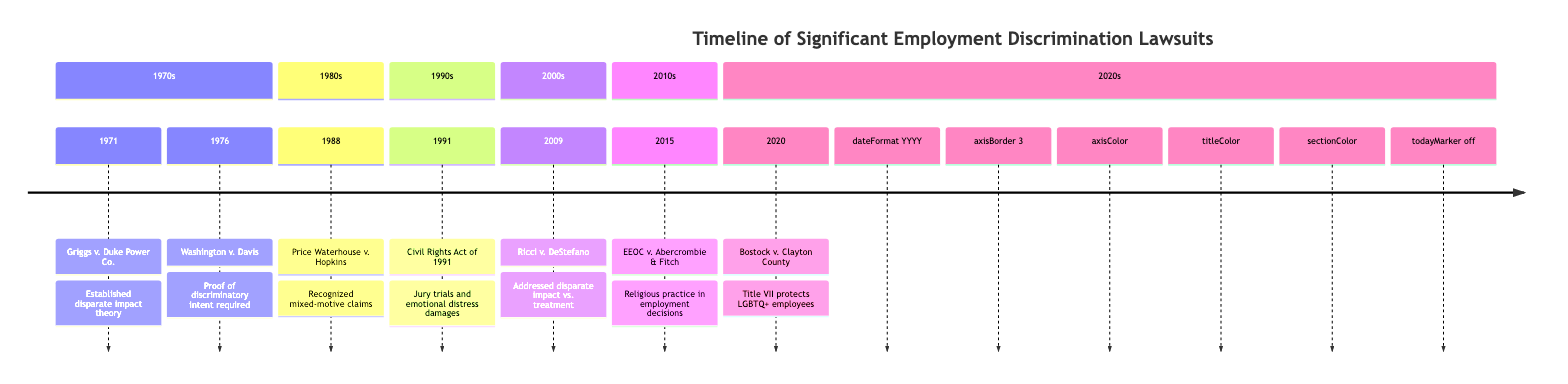What lawsuit established the disparate impact theory? The diagram indicates that the lawsuit Griggs v. Duke Power Co. in 1971 established the disparate impact theory.
Answer: Griggs v. Duke Power Co What year was Price Waterhouse v. Hopkins decided? According to the diagram, Price Waterhouse v. Hopkins was decided in 1988.
Answer: 1988 Which lawsuit required proof of discriminatory intent? The diagram shows that Washington v. Davis from 1976 required proof of discriminatory intent.
Answer: Washington v. Davis How many significant employment discrimination lawsuits are listed in the timeline? By counting the entries in the diagram, there are seven significant employment discrimination lawsuits listed.
Answer: 7 Which case addressed the balance between disparate impact and treatment? The diagram indicates that Ricci v. DeStefano, decided in 2009, addressed the issue of disparate impact versus treatment.
Answer: Ricci v. DeStefano What landmark case in 2015 dealt with religious practice in employment decisions? The diagram names EEOC v. Abercrombie & Fitch as the landmark case in 2015 dealing with religious practices in employment.
Answer: EEOC v. Abercrombie & Fitch What is the significance of Bostock v. Clayton County regarding employee protections? Bostock v. Clayton County is significant because it established that Title VII protects LGBTQ+ employees, as indicated in the diagram for 2020.
Answer: Title VII protects LGBTQ+ employees Which decade saw the introduction of jury trials and emotional distress damages? The diagram notes that this introduction occurred with the Civil Rights Act of 1991, which is in the 1990s.
Answer: 1990s What color represents the sections in the timeline diagram? The sections in the timeline diagram are represented using the color #00CCCC.
Answer: #00CCCC 